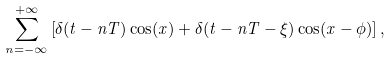<formula> <loc_0><loc_0><loc_500><loc_500>\sum _ { n = - \infty } ^ { + \infty } \left [ \delta ( t - n T ) \cos ( x ) + \delta ( t - n T - \xi ) \cos ( x - \phi ) \right ] ,</formula> 